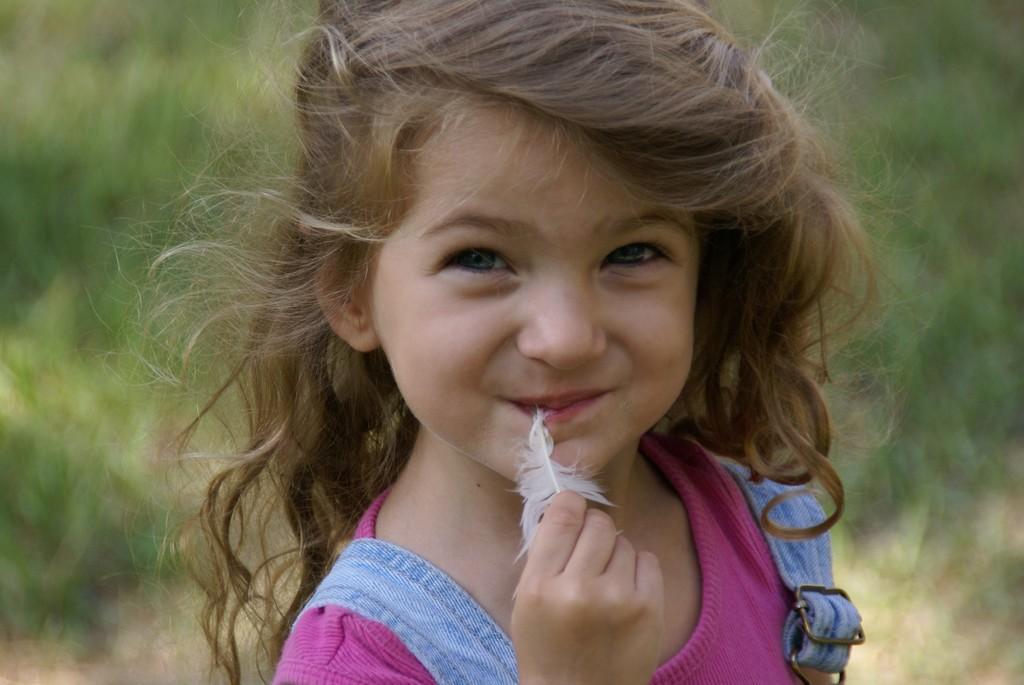In one or two sentences, can you explain what this image depicts? In the image there is a girl in the foreground, it seems like there is a feather in her hand and the girl is smiling, the background of the girl is blur. 